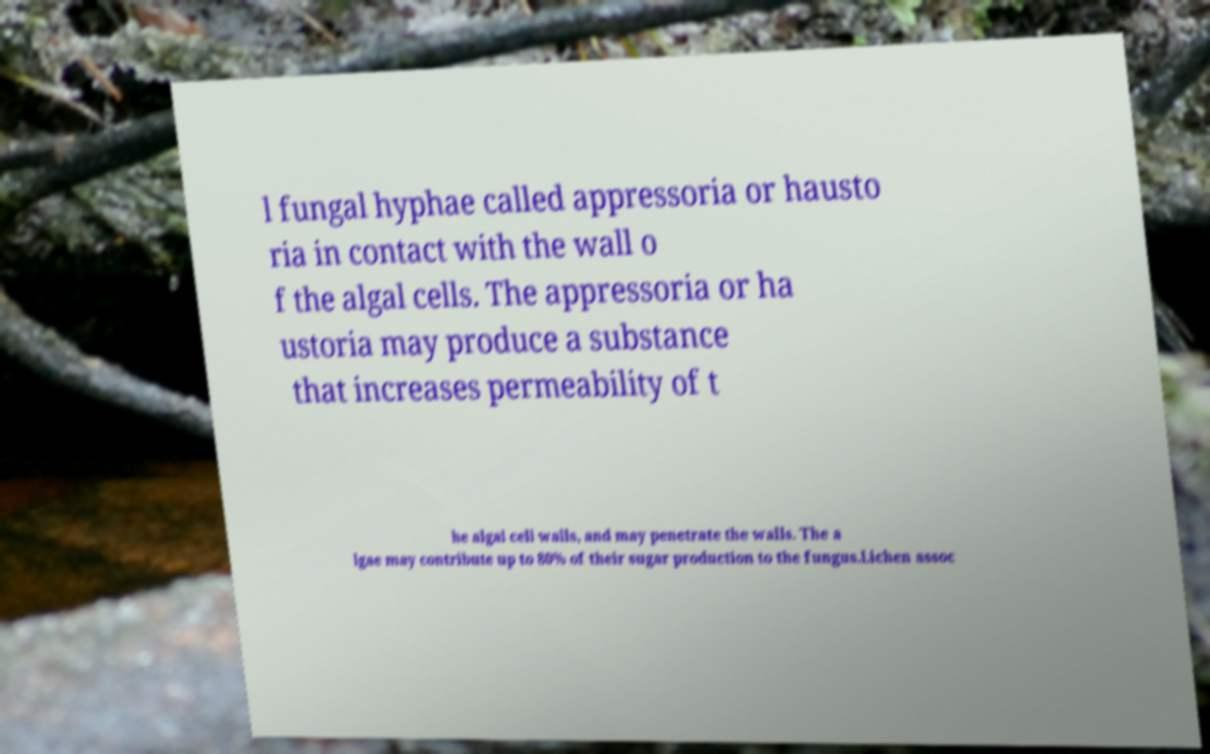Please read and relay the text visible in this image. What does it say? l fungal hyphae called appressoria or hausto ria in contact with the wall o f the algal cells. The appressoria or ha ustoria may produce a substance that increases permeability of t he algal cell walls, and may penetrate the walls. The a lgae may contribute up to 80% of their sugar production to the fungus.Lichen assoc 